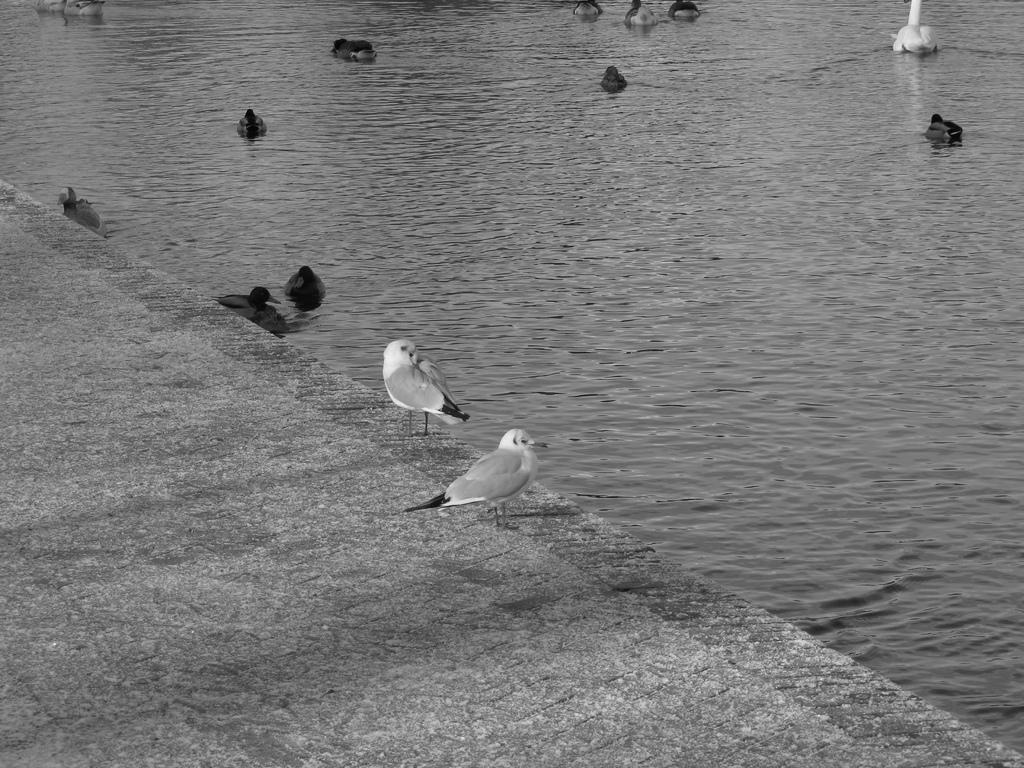What is the primary element in the image? There is water in the image. What can be seen floating on the water? There are birds lying on the water. Are there any birds standing on a surface other than the water? Yes, there are two birds standing on the floor. How does the road affect the quietness of the birds in the image? There is no road present in the image, so it cannot affect the quietness of the birds. 